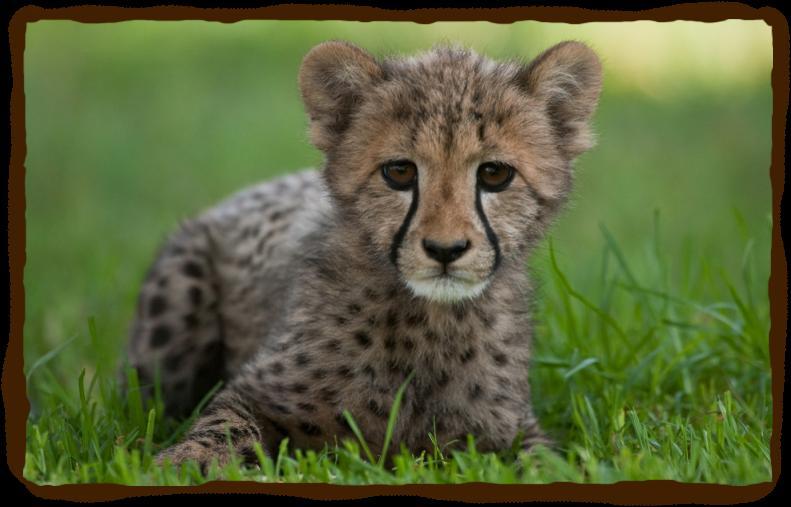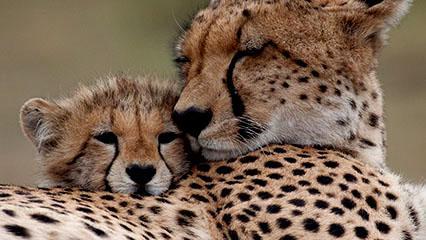The first image is the image on the left, the second image is the image on the right. Assess this claim about the two images: "There are two cats in the image on the right.". Correct or not? Answer yes or no. Yes. 